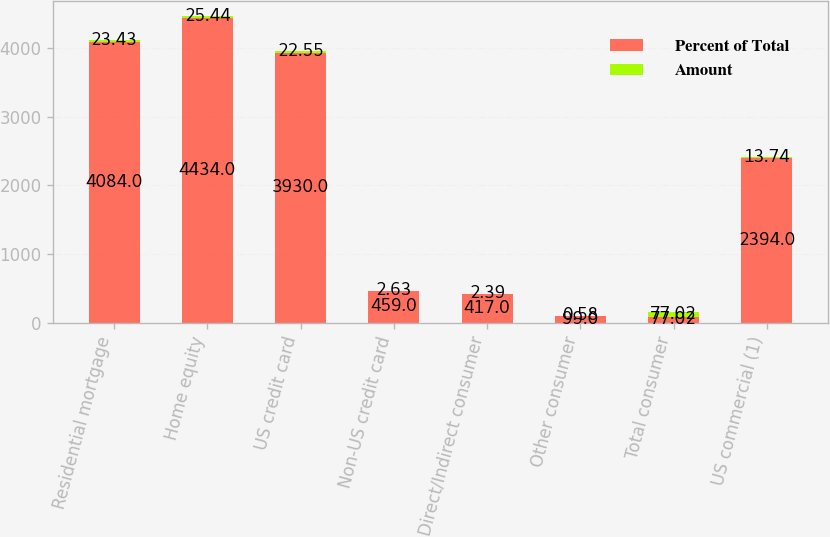<chart> <loc_0><loc_0><loc_500><loc_500><stacked_bar_chart><ecel><fcel>Residential mortgage<fcel>Home equity<fcel>US credit card<fcel>Non-US credit card<fcel>Direct/Indirect consumer<fcel>Other consumer<fcel>Total consumer<fcel>US commercial (1)<nl><fcel>Percent of Total<fcel>4084<fcel>4434<fcel>3930<fcel>459<fcel>417<fcel>99<fcel>77.02<fcel>2394<nl><fcel>Amount<fcel>23.43<fcel>25.44<fcel>22.55<fcel>2.63<fcel>2.39<fcel>0.58<fcel>77.02<fcel>13.74<nl></chart> 